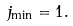<formula> <loc_0><loc_0><loc_500><loc_500>j _ { \min } = 1 .</formula> 